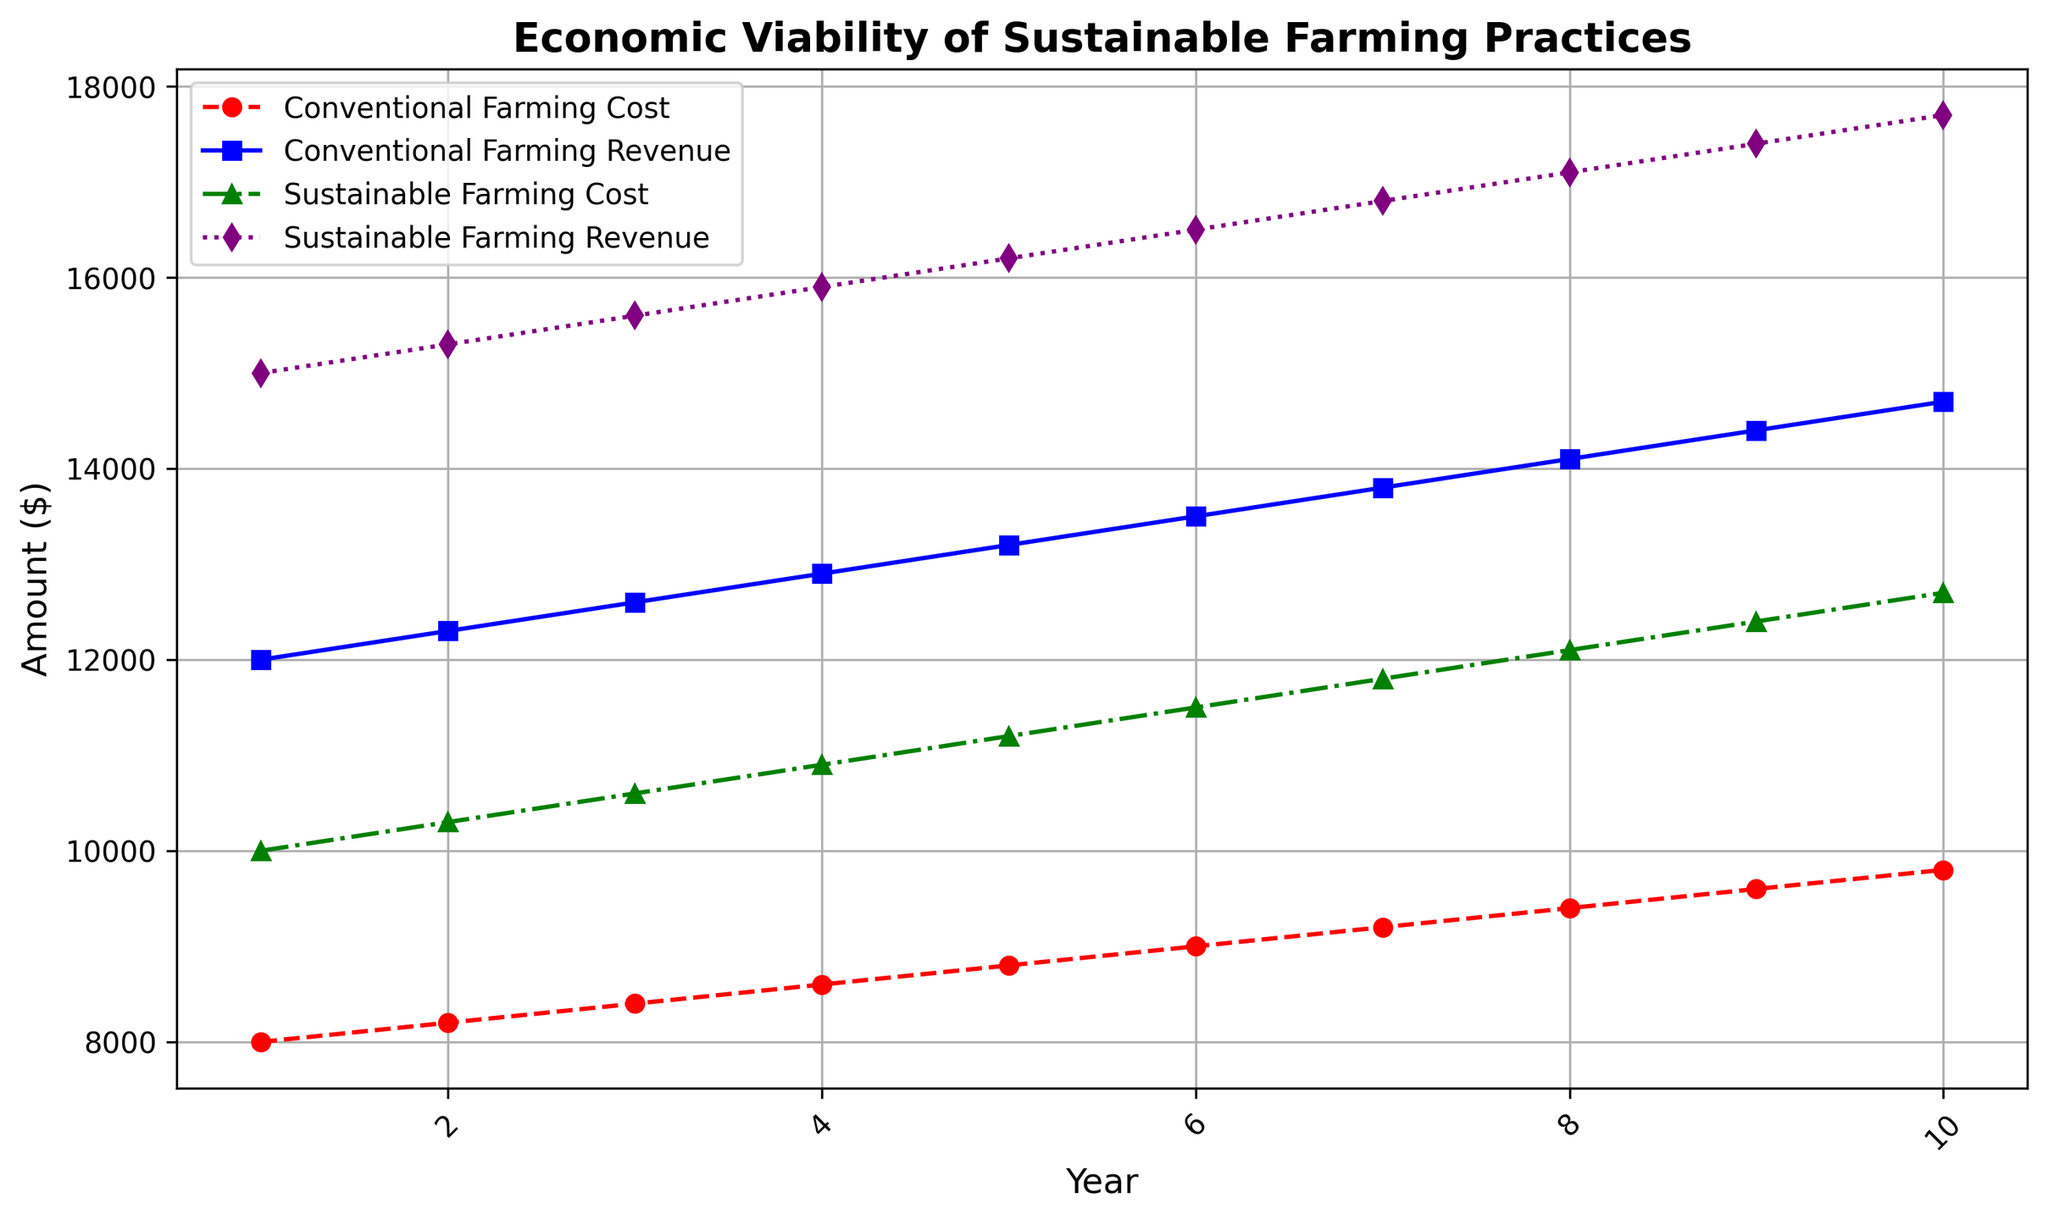What is the cost of conventional farming in the 5th year? Locate the curve labeled "Conventional Farming Cost," which is marked with red circles and dashed lines. Find the data point on this curve corresponding to year 5, which is 8800.
Answer: 8800 Which farming practice yields higher revenue in the 8th year? Compare the data points for the 8th year on the "Conventional Farming Revenue" curve marked with blue squares and the "Sustainable Farming Revenue" curve marked with purple diamonds. The sustainable farming revenue is 17100, whereas the conventional farming revenue is 14100.
Answer: Sustainable farming By how much does the cost of sustainable farming in the 10th year exceed that of the 1st year? Locate the "Sustainable Farming Cost" curve, marked with green triangles and dot-dash lines, and find the data points for years 1 and 10. The values are 10000 and 12700, respectively. Subtract the first-year cost from the tenth-year cost: 12700 - 10000 = 2700.
Answer: 2700 What is the average revenue from conventional farming over the decade? Sum up all the revenue values from "Conventional Farming Revenue" (12000, 12300, 12600, 12900, 13200, 13500, 13800, 14100, 14400, 14700) which equals 133500. Divide by the number of years (10): 133500 / 10 = 13350.
Answer: 13350 In which year does sustainable farming first yield $16000 or more in revenue? Look at the "Sustainable Farming Revenue" curve marked with purple diamonds and dotted lines. The data point meeting the condition is in the 4th year with revenue of 15900, slightly below 16000, so we check the 5th year where revenue is 16200.
Answer: 5th year Is the cost of conventional farming ever higher than that of sustainable farming within the decade? Observe the "Conventional Farming Cost" and "Sustainable Farming Cost" curves. Across all years, the "Conventional Farming Cost" line, marked with red circles and dashes, always lies below the "Sustainable Farming Cost," marked with green triangles and dot-dash lines.
Answer: No What is the difference in revenue between sustainable and conventional farming in the 3rd year? Find the data points for the 3rd year on the "Sustainable Farming Revenue" and "Conventional Farming Revenue" curves. The values are 15600 and 12600, respectively. Calculate the difference: 15600 - 12600 = 3000.
Answer: 3000 In the first year, how much greater is the sustainable farming revenue compared to the sustainable farming cost? Locate the first-year data points for "Sustainable Farming Revenue" and "Sustainable Farming Cost." The values are 15000 and 10000, respectively. Subtract the cost from the revenue: 15000 - 10000 = 5000.
Answer: 5000 In which years does conventional farming show a higher revenue than sustainable farming? Compare the "Conventional Farming Revenue" and "Sustainable Farming Revenue" curves for all 10 years to see if the "Conventional Farming Revenue" (blue squares) ever exceeds "Sustainable Farming Revenue" (purple diamonds). There are no such instances as "Sustainable Farming Revenue" is always higher.
Answer: None 